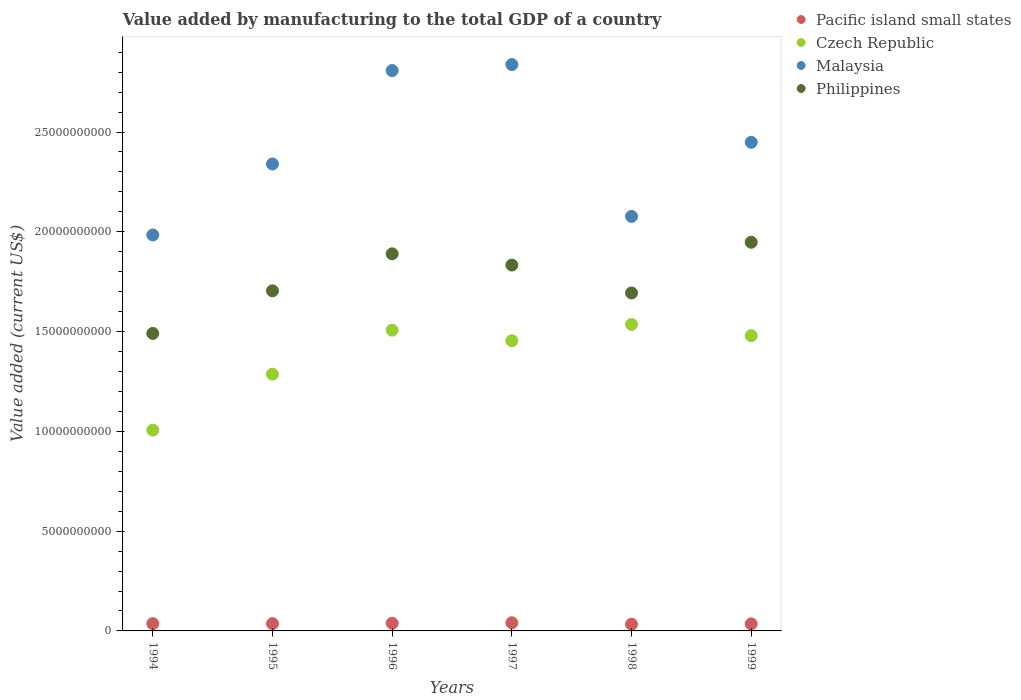How many different coloured dotlines are there?
Your response must be concise. 4. What is the value added by manufacturing to the total GDP in Philippines in 1997?
Offer a terse response. 1.83e+1. Across all years, what is the maximum value added by manufacturing to the total GDP in Malaysia?
Offer a terse response. 2.84e+1. Across all years, what is the minimum value added by manufacturing to the total GDP in Malaysia?
Your response must be concise. 1.98e+1. In which year was the value added by manufacturing to the total GDP in Philippines maximum?
Your response must be concise. 1999. What is the total value added by manufacturing to the total GDP in Malaysia in the graph?
Ensure brevity in your answer.  1.45e+11. What is the difference between the value added by manufacturing to the total GDP in Philippines in 1994 and that in 1999?
Your answer should be compact. -4.57e+09. What is the difference between the value added by manufacturing to the total GDP in Pacific island small states in 1994 and the value added by manufacturing to the total GDP in Philippines in 1999?
Offer a very short reply. -1.91e+1. What is the average value added by manufacturing to the total GDP in Malaysia per year?
Offer a very short reply. 2.42e+1. In the year 1995, what is the difference between the value added by manufacturing to the total GDP in Czech Republic and value added by manufacturing to the total GDP in Philippines?
Keep it short and to the point. -4.18e+09. In how many years, is the value added by manufacturing to the total GDP in Malaysia greater than 11000000000 US$?
Your response must be concise. 6. What is the ratio of the value added by manufacturing to the total GDP in Czech Republic in 1994 to that in 1995?
Provide a short and direct response. 0.78. What is the difference between the highest and the second highest value added by manufacturing to the total GDP in Malaysia?
Provide a short and direct response. 3.01e+08. What is the difference between the highest and the lowest value added by manufacturing to the total GDP in Philippines?
Ensure brevity in your answer.  4.57e+09. Is the sum of the value added by manufacturing to the total GDP in Malaysia in 1995 and 1999 greater than the maximum value added by manufacturing to the total GDP in Czech Republic across all years?
Keep it short and to the point. Yes. Is the value added by manufacturing to the total GDP in Philippines strictly greater than the value added by manufacturing to the total GDP in Czech Republic over the years?
Provide a succinct answer. Yes. Is the value added by manufacturing to the total GDP in Philippines strictly less than the value added by manufacturing to the total GDP in Pacific island small states over the years?
Offer a terse response. No. How many years are there in the graph?
Provide a short and direct response. 6. What is the difference between two consecutive major ticks on the Y-axis?
Offer a very short reply. 5.00e+09. Are the values on the major ticks of Y-axis written in scientific E-notation?
Offer a terse response. No. How are the legend labels stacked?
Provide a succinct answer. Vertical. What is the title of the graph?
Provide a short and direct response. Value added by manufacturing to the total GDP of a country. Does "West Bank and Gaza" appear as one of the legend labels in the graph?
Provide a short and direct response. No. What is the label or title of the X-axis?
Your answer should be very brief. Years. What is the label or title of the Y-axis?
Offer a very short reply. Value added (current US$). What is the Value added (current US$) of Pacific island small states in 1994?
Provide a succinct answer. 3.66e+08. What is the Value added (current US$) of Czech Republic in 1994?
Your answer should be compact. 1.01e+1. What is the Value added (current US$) of Malaysia in 1994?
Your answer should be compact. 1.98e+1. What is the Value added (current US$) in Philippines in 1994?
Offer a very short reply. 1.49e+1. What is the Value added (current US$) in Pacific island small states in 1995?
Your answer should be very brief. 3.65e+08. What is the Value added (current US$) in Czech Republic in 1995?
Make the answer very short. 1.29e+1. What is the Value added (current US$) in Malaysia in 1995?
Your response must be concise. 2.34e+1. What is the Value added (current US$) in Philippines in 1995?
Offer a terse response. 1.70e+1. What is the Value added (current US$) in Pacific island small states in 1996?
Offer a terse response. 3.83e+08. What is the Value added (current US$) in Czech Republic in 1996?
Your answer should be compact. 1.51e+1. What is the Value added (current US$) of Malaysia in 1996?
Your answer should be very brief. 2.81e+1. What is the Value added (current US$) of Philippines in 1996?
Ensure brevity in your answer.  1.89e+1. What is the Value added (current US$) in Pacific island small states in 1997?
Offer a terse response. 4.08e+08. What is the Value added (current US$) of Czech Republic in 1997?
Offer a terse response. 1.45e+1. What is the Value added (current US$) in Malaysia in 1997?
Ensure brevity in your answer.  2.84e+1. What is the Value added (current US$) of Philippines in 1997?
Your answer should be very brief. 1.83e+1. What is the Value added (current US$) in Pacific island small states in 1998?
Ensure brevity in your answer.  3.37e+08. What is the Value added (current US$) of Czech Republic in 1998?
Your answer should be compact. 1.54e+1. What is the Value added (current US$) of Malaysia in 1998?
Your response must be concise. 2.08e+1. What is the Value added (current US$) of Philippines in 1998?
Offer a very short reply. 1.69e+1. What is the Value added (current US$) of Pacific island small states in 1999?
Your answer should be very brief. 3.54e+08. What is the Value added (current US$) of Czech Republic in 1999?
Make the answer very short. 1.48e+1. What is the Value added (current US$) in Malaysia in 1999?
Offer a very short reply. 2.45e+1. What is the Value added (current US$) of Philippines in 1999?
Give a very brief answer. 1.95e+1. Across all years, what is the maximum Value added (current US$) in Pacific island small states?
Your answer should be compact. 4.08e+08. Across all years, what is the maximum Value added (current US$) in Czech Republic?
Provide a succinct answer. 1.54e+1. Across all years, what is the maximum Value added (current US$) in Malaysia?
Provide a succinct answer. 2.84e+1. Across all years, what is the maximum Value added (current US$) of Philippines?
Keep it short and to the point. 1.95e+1. Across all years, what is the minimum Value added (current US$) in Pacific island small states?
Your answer should be very brief. 3.37e+08. Across all years, what is the minimum Value added (current US$) of Czech Republic?
Your answer should be very brief. 1.01e+1. Across all years, what is the minimum Value added (current US$) in Malaysia?
Ensure brevity in your answer.  1.98e+1. Across all years, what is the minimum Value added (current US$) of Philippines?
Provide a succinct answer. 1.49e+1. What is the total Value added (current US$) of Pacific island small states in the graph?
Offer a terse response. 2.21e+09. What is the total Value added (current US$) of Czech Republic in the graph?
Keep it short and to the point. 8.27e+1. What is the total Value added (current US$) of Malaysia in the graph?
Give a very brief answer. 1.45e+11. What is the total Value added (current US$) of Philippines in the graph?
Your response must be concise. 1.06e+11. What is the difference between the Value added (current US$) in Pacific island small states in 1994 and that in 1995?
Make the answer very short. 1.14e+06. What is the difference between the Value added (current US$) in Czech Republic in 1994 and that in 1995?
Offer a terse response. -2.81e+09. What is the difference between the Value added (current US$) in Malaysia in 1994 and that in 1995?
Make the answer very short. -3.56e+09. What is the difference between the Value added (current US$) of Philippines in 1994 and that in 1995?
Make the answer very short. -2.14e+09. What is the difference between the Value added (current US$) of Pacific island small states in 1994 and that in 1996?
Your answer should be compact. -1.69e+07. What is the difference between the Value added (current US$) of Czech Republic in 1994 and that in 1996?
Offer a terse response. -5.01e+09. What is the difference between the Value added (current US$) in Malaysia in 1994 and that in 1996?
Your answer should be very brief. -8.24e+09. What is the difference between the Value added (current US$) in Philippines in 1994 and that in 1996?
Your response must be concise. -3.99e+09. What is the difference between the Value added (current US$) of Pacific island small states in 1994 and that in 1997?
Make the answer very short. -4.11e+07. What is the difference between the Value added (current US$) of Czech Republic in 1994 and that in 1997?
Provide a short and direct response. -4.48e+09. What is the difference between the Value added (current US$) of Malaysia in 1994 and that in 1997?
Keep it short and to the point. -8.54e+09. What is the difference between the Value added (current US$) in Philippines in 1994 and that in 1997?
Keep it short and to the point. -3.43e+09. What is the difference between the Value added (current US$) of Pacific island small states in 1994 and that in 1998?
Offer a very short reply. 2.93e+07. What is the difference between the Value added (current US$) in Czech Republic in 1994 and that in 1998?
Your response must be concise. -5.30e+09. What is the difference between the Value added (current US$) of Malaysia in 1994 and that in 1998?
Offer a very short reply. -9.30e+08. What is the difference between the Value added (current US$) in Philippines in 1994 and that in 1998?
Make the answer very short. -2.03e+09. What is the difference between the Value added (current US$) of Pacific island small states in 1994 and that in 1999?
Keep it short and to the point. 1.28e+07. What is the difference between the Value added (current US$) of Czech Republic in 1994 and that in 1999?
Ensure brevity in your answer.  -4.74e+09. What is the difference between the Value added (current US$) of Malaysia in 1994 and that in 1999?
Give a very brief answer. -4.64e+09. What is the difference between the Value added (current US$) in Philippines in 1994 and that in 1999?
Keep it short and to the point. -4.57e+09. What is the difference between the Value added (current US$) of Pacific island small states in 1995 and that in 1996?
Offer a very short reply. -1.80e+07. What is the difference between the Value added (current US$) in Czech Republic in 1995 and that in 1996?
Give a very brief answer. -2.21e+09. What is the difference between the Value added (current US$) of Malaysia in 1995 and that in 1996?
Provide a short and direct response. -4.68e+09. What is the difference between the Value added (current US$) in Philippines in 1995 and that in 1996?
Your response must be concise. -1.85e+09. What is the difference between the Value added (current US$) in Pacific island small states in 1995 and that in 1997?
Your answer should be very brief. -4.23e+07. What is the difference between the Value added (current US$) in Czech Republic in 1995 and that in 1997?
Your answer should be very brief. -1.68e+09. What is the difference between the Value added (current US$) in Malaysia in 1995 and that in 1997?
Your answer should be compact. -4.98e+09. What is the difference between the Value added (current US$) of Philippines in 1995 and that in 1997?
Your answer should be compact. -1.29e+09. What is the difference between the Value added (current US$) in Pacific island small states in 1995 and that in 1998?
Your response must be concise. 2.82e+07. What is the difference between the Value added (current US$) of Czech Republic in 1995 and that in 1998?
Give a very brief answer. -2.49e+09. What is the difference between the Value added (current US$) in Malaysia in 1995 and that in 1998?
Offer a terse response. 2.63e+09. What is the difference between the Value added (current US$) in Philippines in 1995 and that in 1998?
Provide a short and direct response. 1.06e+08. What is the difference between the Value added (current US$) of Pacific island small states in 1995 and that in 1999?
Your response must be concise. 1.17e+07. What is the difference between the Value added (current US$) of Czech Republic in 1995 and that in 1999?
Offer a very short reply. -1.93e+09. What is the difference between the Value added (current US$) of Malaysia in 1995 and that in 1999?
Provide a succinct answer. -1.09e+09. What is the difference between the Value added (current US$) in Philippines in 1995 and that in 1999?
Keep it short and to the point. -2.43e+09. What is the difference between the Value added (current US$) in Pacific island small states in 1996 and that in 1997?
Your answer should be compact. -2.43e+07. What is the difference between the Value added (current US$) in Czech Republic in 1996 and that in 1997?
Your response must be concise. 5.29e+08. What is the difference between the Value added (current US$) of Malaysia in 1996 and that in 1997?
Keep it short and to the point. -3.01e+08. What is the difference between the Value added (current US$) of Philippines in 1996 and that in 1997?
Your answer should be compact. 5.63e+08. What is the difference between the Value added (current US$) in Pacific island small states in 1996 and that in 1998?
Ensure brevity in your answer.  4.62e+07. What is the difference between the Value added (current US$) of Czech Republic in 1996 and that in 1998?
Ensure brevity in your answer.  -2.86e+08. What is the difference between the Value added (current US$) of Malaysia in 1996 and that in 1998?
Offer a terse response. 7.31e+09. What is the difference between the Value added (current US$) of Philippines in 1996 and that in 1998?
Keep it short and to the point. 1.96e+09. What is the difference between the Value added (current US$) of Pacific island small states in 1996 and that in 1999?
Offer a terse response. 2.97e+07. What is the difference between the Value added (current US$) of Czech Republic in 1996 and that in 1999?
Your response must be concise. 2.75e+08. What is the difference between the Value added (current US$) in Malaysia in 1996 and that in 1999?
Your answer should be compact. 3.60e+09. What is the difference between the Value added (current US$) of Philippines in 1996 and that in 1999?
Provide a short and direct response. -5.80e+08. What is the difference between the Value added (current US$) in Pacific island small states in 1997 and that in 1998?
Your answer should be compact. 7.04e+07. What is the difference between the Value added (current US$) of Czech Republic in 1997 and that in 1998?
Provide a short and direct response. -8.15e+08. What is the difference between the Value added (current US$) of Malaysia in 1997 and that in 1998?
Give a very brief answer. 7.61e+09. What is the difference between the Value added (current US$) of Philippines in 1997 and that in 1998?
Offer a very short reply. 1.40e+09. What is the difference between the Value added (current US$) in Pacific island small states in 1997 and that in 1999?
Your response must be concise. 5.40e+07. What is the difference between the Value added (current US$) in Czech Republic in 1997 and that in 1999?
Ensure brevity in your answer.  -2.54e+08. What is the difference between the Value added (current US$) in Malaysia in 1997 and that in 1999?
Your answer should be very brief. 3.90e+09. What is the difference between the Value added (current US$) in Philippines in 1997 and that in 1999?
Provide a succinct answer. -1.14e+09. What is the difference between the Value added (current US$) in Pacific island small states in 1998 and that in 1999?
Your response must be concise. -1.65e+07. What is the difference between the Value added (current US$) of Czech Republic in 1998 and that in 1999?
Offer a terse response. 5.62e+08. What is the difference between the Value added (current US$) in Malaysia in 1998 and that in 1999?
Provide a short and direct response. -3.71e+09. What is the difference between the Value added (current US$) of Philippines in 1998 and that in 1999?
Your response must be concise. -2.54e+09. What is the difference between the Value added (current US$) in Pacific island small states in 1994 and the Value added (current US$) in Czech Republic in 1995?
Keep it short and to the point. -1.25e+1. What is the difference between the Value added (current US$) in Pacific island small states in 1994 and the Value added (current US$) in Malaysia in 1995?
Give a very brief answer. -2.30e+1. What is the difference between the Value added (current US$) of Pacific island small states in 1994 and the Value added (current US$) of Philippines in 1995?
Your answer should be compact. -1.67e+1. What is the difference between the Value added (current US$) of Czech Republic in 1994 and the Value added (current US$) of Malaysia in 1995?
Your answer should be very brief. -1.33e+1. What is the difference between the Value added (current US$) of Czech Republic in 1994 and the Value added (current US$) of Philippines in 1995?
Provide a succinct answer. -6.98e+09. What is the difference between the Value added (current US$) of Malaysia in 1994 and the Value added (current US$) of Philippines in 1995?
Provide a succinct answer. 2.80e+09. What is the difference between the Value added (current US$) of Pacific island small states in 1994 and the Value added (current US$) of Czech Republic in 1996?
Provide a succinct answer. -1.47e+1. What is the difference between the Value added (current US$) of Pacific island small states in 1994 and the Value added (current US$) of Malaysia in 1996?
Your response must be concise. -2.77e+1. What is the difference between the Value added (current US$) of Pacific island small states in 1994 and the Value added (current US$) of Philippines in 1996?
Make the answer very short. -1.85e+1. What is the difference between the Value added (current US$) in Czech Republic in 1994 and the Value added (current US$) in Malaysia in 1996?
Your answer should be compact. -1.80e+1. What is the difference between the Value added (current US$) of Czech Republic in 1994 and the Value added (current US$) of Philippines in 1996?
Ensure brevity in your answer.  -8.84e+09. What is the difference between the Value added (current US$) in Malaysia in 1994 and the Value added (current US$) in Philippines in 1996?
Your answer should be compact. 9.45e+08. What is the difference between the Value added (current US$) in Pacific island small states in 1994 and the Value added (current US$) in Czech Republic in 1997?
Provide a short and direct response. -1.42e+1. What is the difference between the Value added (current US$) of Pacific island small states in 1994 and the Value added (current US$) of Malaysia in 1997?
Provide a succinct answer. -2.80e+1. What is the difference between the Value added (current US$) of Pacific island small states in 1994 and the Value added (current US$) of Philippines in 1997?
Offer a terse response. -1.80e+1. What is the difference between the Value added (current US$) in Czech Republic in 1994 and the Value added (current US$) in Malaysia in 1997?
Keep it short and to the point. -1.83e+1. What is the difference between the Value added (current US$) of Czech Republic in 1994 and the Value added (current US$) of Philippines in 1997?
Your response must be concise. -8.27e+09. What is the difference between the Value added (current US$) in Malaysia in 1994 and the Value added (current US$) in Philippines in 1997?
Give a very brief answer. 1.51e+09. What is the difference between the Value added (current US$) in Pacific island small states in 1994 and the Value added (current US$) in Czech Republic in 1998?
Make the answer very short. -1.50e+1. What is the difference between the Value added (current US$) in Pacific island small states in 1994 and the Value added (current US$) in Malaysia in 1998?
Offer a very short reply. -2.04e+1. What is the difference between the Value added (current US$) of Pacific island small states in 1994 and the Value added (current US$) of Philippines in 1998?
Offer a very short reply. -1.66e+1. What is the difference between the Value added (current US$) of Czech Republic in 1994 and the Value added (current US$) of Malaysia in 1998?
Offer a terse response. -1.07e+1. What is the difference between the Value added (current US$) of Czech Republic in 1994 and the Value added (current US$) of Philippines in 1998?
Keep it short and to the point. -6.88e+09. What is the difference between the Value added (current US$) in Malaysia in 1994 and the Value added (current US$) in Philippines in 1998?
Offer a very short reply. 2.90e+09. What is the difference between the Value added (current US$) in Pacific island small states in 1994 and the Value added (current US$) in Czech Republic in 1999?
Offer a very short reply. -1.44e+1. What is the difference between the Value added (current US$) in Pacific island small states in 1994 and the Value added (current US$) in Malaysia in 1999?
Offer a very short reply. -2.41e+1. What is the difference between the Value added (current US$) in Pacific island small states in 1994 and the Value added (current US$) in Philippines in 1999?
Your response must be concise. -1.91e+1. What is the difference between the Value added (current US$) of Czech Republic in 1994 and the Value added (current US$) of Malaysia in 1999?
Ensure brevity in your answer.  -1.44e+1. What is the difference between the Value added (current US$) in Czech Republic in 1994 and the Value added (current US$) in Philippines in 1999?
Provide a succinct answer. -9.42e+09. What is the difference between the Value added (current US$) in Malaysia in 1994 and the Value added (current US$) in Philippines in 1999?
Offer a terse response. 3.65e+08. What is the difference between the Value added (current US$) of Pacific island small states in 1995 and the Value added (current US$) of Czech Republic in 1996?
Ensure brevity in your answer.  -1.47e+1. What is the difference between the Value added (current US$) in Pacific island small states in 1995 and the Value added (current US$) in Malaysia in 1996?
Provide a short and direct response. -2.77e+1. What is the difference between the Value added (current US$) of Pacific island small states in 1995 and the Value added (current US$) of Philippines in 1996?
Keep it short and to the point. -1.85e+1. What is the difference between the Value added (current US$) in Czech Republic in 1995 and the Value added (current US$) in Malaysia in 1996?
Offer a very short reply. -1.52e+1. What is the difference between the Value added (current US$) of Czech Republic in 1995 and the Value added (current US$) of Philippines in 1996?
Your answer should be very brief. -6.03e+09. What is the difference between the Value added (current US$) of Malaysia in 1995 and the Value added (current US$) of Philippines in 1996?
Keep it short and to the point. 4.50e+09. What is the difference between the Value added (current US$) of Pacific island small states in 1995 and the Value added (current US$) of Czech Republic in 1997?
Your answer should be compact. -1.42e+1. What is the difference between the Value added (current US$) of Pacific island small states in 1995 and the Value added (current US$) of Malaysia in 1997?
Your answer should be compact. -2.80e+1. What is the difference between the Value added (current US$) of Pacific island small states in 1995 and the Value added (current US$) of Philippines in 1997?
Make the answer very short. -1.80e+1. What is the difference between the Value added (current US$) in Czech Republic in 1995 and the Value added (current US$) in Malaysia in 1997?
Your answer should be compact. -1.55e+1. What is the difference between the Value added (current US$) in Czech Republic in 1995 and the Value added (current US$) in Philippines in 1997?
Give a very brief answer. -5.47e+09. What is the difference between the Value added (current US$) in Malaysia in 1995 and the Value added (current US$) in Philippines in 1997?
Your answer should be very brief. 5.07e+09. What is the difference between the Value added (current US$) of Pacific island small states in 1995 and the Value added (current US$) of Czech Republic in 1998?
Offer a terse response. -1.50e+1. What is the difference between the Value added (current US$) of Pacific island small states in 1995 and the Value added (current US$) of Malaysia in 1998?
Make the answer very short. -2.04e+1. What is the difference between the Value added (current US$) of Pacific island small states in 1995 and the Value added (current US$) of Philippines in 1998?
Ensure brevity in your answer.  -1.66e+1. What is the difference between the Value added (current US$) of Czech Republic in 1995 and the Value added (current US$) of Malaysia in 1998?
Ensure brevity in your answer.  -7.90e+09. What is the difference between the Value added (current US$) in Czech Republic in 1995 and the Value added (current US$) in Philippines in 1998?
Your answer should be compact. -4.07e+09. What is the difference between the Value added (current US$) of Malaysia in 1995 and the Value added (current US$) of Philippines in 1998?
Keep it short and to the point. 6.46e+09. What is the difference between the Value added (current US$) of Pacific island small states in 1995 and the Value added (current US$) of Czech Republic in 1999?
Your answer should be very brief. -1.44e+1. What is the difference between the Value added (current US$) of Pacific island small states in 1995 and the Value added (current US$) of Malaysia in 1999?
Your answer should be compact. -2.41e+1. What is the difference between the Value added (current US$) of Pacific island small states in 1995 and the Value added (current US$) of Philippines in 1999?
Provide a short and direct response. -1.91e+1. What is the difference between the Value added (current US$) of Czech Republic in 1995 and the Value added (current US$) of Malaysia in 1999?
Provide a succinct answer. -1.16e+1. What is the difference between the Value added (current US$) in Czech Republic in 1995 and the Value added (current US$) in Philippines in 1999?
Keep it short and to the point. -6.61e+09. What is the difference between the Value added (current US$) in Malaysia in 1995 and the Value added (current US$) in Philippines in 1999?
Provide a succinct answer. 3.92e+09. What is the difference between the Value added (current US$) of Pacific island small states in 1996 and the Value added (current US$) of Czech Republic in 1997?
Provide a short and direct response. -1.42e+1. What is the difference between the Value added (current US$) of Pacific island small states in 1996 and the Value added (current US$) of Malaysia in 1997?
Make the answer very short. -2.80e+1. What is the difference between the Value added (current US$) in Pacific island small states in 1996 and the Value added (current US$) in Philippines in 1997?
Keep it short and to the point. -1.80e+1. What is the difference between the Value added (current US$) in Czech Republic in 1996 and the Value added (current US$) in Malaysia in 1997?
Make the answer very short. -1.33e+1. What is the difference between the Value added (current US$) of Czech Republic in 1996 and the Value added (current US$) of Philippines in 1997?
Make the answer very short. -3.26e+09. What is the difference between the Value added (current US$) in Malaysia in 1996 and the Value added (current US$) in Philippines in 1997?
Offer a terse response. 9.75e+09. What is the difference between the Value added (current US$) of Pacific island small states in 1996 and the Value added (current US$) of Czech Republic in 1998?
Provide a short and direct response. -1.50e+1. What is the difference between the Value added (current US$) of Pacific island small states in 1996 and the Value added (current US$) of Malaysia in 1998?
Your response must be concise. -2.04e+1. What is the difference between the Value added (current US$) of Pacific island small states in 1996 and the Value added (current US$) of Philippines in 1998?
Keep it short and to the point. -1.66e+1. What is the difference between the Value added (current US$) of Czech Republic in 1996 and the Value added (current US$) of Malaysia in 1998?
Your response must be concise. -5.70e+09. What is the difference between the Value added (current US$) in Czech Republic in 1996 and the Value added (current US$) in Philippines in 1998?
Offer a very short reply. -1.86e+09. What is the difference between the Value added (current US$) of Malaysia in 1996 and the Value added (current US$) of Philippines in 1998?
Your response must be concise. 1.11e+1. What is the difference between the Value added (current US$) in Pacific island small states in 1996 and the Value added (current US$) in Czech Republic in 1999?
Offer a very short reply. -1.44e+1. What is the difference between the Value added (current US$) of Pacific island small states in 1996 and the Value added (current US$) of Malaysia in 1999?
Provide a short and direct response. -2.41e+1. What is the difference between the Value added (current US$) in Pacific island small states in 1996 and the Value added (current US$) in Philippines in 1999?
Provide a succinct answer. -1.91e+1. What is the difference between the Value added (current US$) of Czech Republic in 1996 and the Value added (current US$) of Malaysia in 1999?
Provide a succinct answer. -9.41e+09. What is the difference between the Value added (current US$) in Czech Republic in 1996 and the Value added (current US$) in Philippines in 1999?
Offer a very short reply. -4.40e+09. What is the difference between the Value added (current US$) in Malaysia in 1996 and the Value added (current US$) in Philippines in 1999?
Make the answer very short. 8.60e+09. What is the difference between the Value added (current US$) of Pacific island small states in 1997 and the Value added (current US$) of Czech Republic in 1998?
Ensure brevity in your answer.  -1.50e+1. What is the difference between the Value added (current US$) in Pacific island small states in 1997 and the Value added (current US$) in Malaysia in 1998?
Make the answer very short. -2.04e+1. What is the difference between the Value added (current US$) of Pacific island small states in 1997 and the Value added (current US$) of Philippines in 1998?
Your response must be concise. -1.65e+1. What is the difference between the Value added (current US$) in Czech Republic in 1997 and the Value added (current US$) in Malaysia in 1998?
Provide a succinct answer. -6.23e+09. What is the difference between the Value added (current US$) in Czech Republic in 1997 and the Value added (current US$) in Philippines in 1998?
Provide a short and direct response. -2.39e+09. What is the difference between the Value added (current US$) of Malaysia in 1997 and the Value added (current US$) of Philippines in 1998?
Keep it short and to the point. 1.14e+1. What is the difference between the Value added (current US$) of Pacific island small states in 1997 and the Value added (current US$) of Czech Republic in 1999?
Ensure brevity in your answer.  -1.44e+1. What is the difference between the Value added (current US$) in Pacific island small states in 1997 and the Value added (current US$) in Malaysia in 1999?
Offer a very short reply. -2.41e+1. What is the difference between the Value added (current US$) in Pacific island small states in 1997 and the Value added (current US$) in Philippines in 1999?
Provide a short and direct response. -1.91e+1. What is the difference between the Value added (current US$) of Czech Republic in 1997 and the Value added (current US$) of Malaysia in 1999?
Keep it short and to the point. -9.94e+09. What is the difference between the Value added (current US$) of Czech Republic in 1997 and the Value added (current US$) of Philippines in 1999?
Your answer should be very brief. -4.93e+09. What is the difference between the Value added (current US$) of Malaysia in 1997 and the Value added (current US$) of Philippines in 1999?
Offer a terse response. 8.90e+09. What is the difference between the Value added (current US$) in Pacific island small states in 1998 and the Value added (current US$) in Czech Republic in 1999?
Offer a terse response. -1.45e+1. What is the difference between the Value added (current US$) in Pacific island small states in 1998 and the Value added (current US$) in Malaysia in 1999?
Provide a short and direct response. -2.41e+1. What is the difference between the Value added (current US$) of Pacific island small states in 1998 and the Value added (current US$) of Philippines in 1999?
Keep it short and to the point. -1.91e+1. What is the difference between the Value added (current US$) in Czech Republic in 1998 and the Value added (current US$) in Malaysia in 1999?
Ensure brevity in your answer.  -9.13e+09. What is the difference between the Value added (current US$) of Czech Republic in 1998 and the Value added (current US$) of Philippines in 1999?
Make the answer very short. -4.12e+09. What is the difference between the Value added (current US$) of Malaysia in 1998 and the Value added (current US$) of Philippines in 1999?
Offer a terse response. 1.30e+09. What is the average Value added (current US$) of Pacific island small states per year?
Give a very brief answer. 3.69e+08. What is the average Value added (current US$) of Czech Republic per year?
Offer a very short reply. 1.38e+1. What is the average Value added (current US$) of Malaysia per year?
Keep it short and to the point. 2.42e+1. What is the average Value added (current US$) in Philippines per year?
Your answer should be very brief. 1.76e+1. In the year 1994, what is the difference between the Value added (current US$) in Pacific island small states and Value added (current US$) in Czech Republic?
Give a very brief answer. -9.69e+09. In the year 1994, what is the difference between the Value added (current US$) of Pacific island small states and Value added (current US$) of Malaysia?
Your response must be concise. -1.95e+1. In the year 1994, what is the difference between the Value added (current US$) in Pacific island small states and Value added (current US$) in Philippines?
Provide a succinct answer. -1.45e+1. In the year 1994, what is the difference between the Value added (current US$) of Czech Republic and Value added (current US$) of Malaysia?
Your answer should be very brief. -9.78e+09. In the year 1994, what is the difference between the Value added (current US$) of Czech Republic and Value added (current US$) of Philippines?
Make the answer very short. -4.85e+09. In the year 1994, what is the difference between the Value added (current US$) of Malaysia and Value added (current US$) of Philippines?
Provide a short and direct response. 4.93e+09. In the year 1995, what is the difference between the Value added (current US$) in Pacific island small states and Value added (current US$) in Czech Republic?
Ensure brevity in your answer.  -1.25e+1. In the year 1995, what is the difference between the Value added (current US$) of Pacific island small states and Value added (current US$) of Malaysia?
Keep it short and to the point. -2.30e+1. In the year 1995, what is the difference between the Value added (current US$) of Pacific island small states and Value added (current US$) of Philippines?
Your answer should be very brief. -1.67e+1. In the year 1995, what is the difference between the Value added (current US$) in Czech Republic and Value added (current US$) in Malaysia?
Provide a succinct answer. -1.05e+1. In the year 1995, what is the difference between the Value added (current US$) of Czech Republic and Value added (current US$) of Philippines?
Give a very brief answer. -4.18e+09. In the year 1995, what is the difference between the Value added (current US$) in Malaysia and Value added (current US$) in Philippines?
Keep it short and to the point. 6.36e+09. In the year 1996, what is the difference between the Value added (current US$) in Pacific island small states and Value added (current US$) in Czech Republic?
Ensure brevity in your answer.  -1.47e+1. In the year 1996, what is the difference between the Value added (current US$) of Pacific island small states and Value added (current US$) of Malaysia?
Provide a short and direct response. -2.77e+1. In the year 1996, what is the difference between the Value added (current US$) in Pacific island small states and Value added (current US$) in Philippines?
Provide a succinct answer. -1.85e+1. In the year 1996, what is the difference between the Value added (current US$) in Czech Republic and Value added (current US$) in Malaysia?
Give a very brief answer. -1.30e+1. In the year 1996, what is the difference between the Value added (current US$) in Czech Republic and Value added (current US$) in Philippines?
Provide a succinct answer. -3.82e+09. In the year 1996, what is the difference between the Value added (current US$) in Malaysia and Value added (current US$) in Philippines?
Give a very brief answer. 9.18e+09. In the year 1997, what is the difference between the Value added (current US$) of Pacific island small states and Value added (current US$) of Czech Republic?
Give a very brief answer. -1.41e+1. In the year 1997, what is the difference between the Value added (current US$) of Pacific island small states and Value added (current US$) of Malaysia?
Keep it short and to the point. -2.80e+1. In the year 1997, what is the difference between the Value added (current US$) of Pacific island small states and Value added (current US$) of Philippines?
Give a very brief answer. -1.79e+1. In the year 1997, what is the difference between the Value added (current US$) in Czech Republic and Value added (current US$) in Malaysia?
Offer a very short reply. -1.38e+1. In the year 1997, what is the difference between the Value added (current US$) in Czech Republic and Value added (current US$) in Philippines?
Ensure brevity in your answer.  -3.79e+09. In the year 1997, what is the difference between the Value added (current US$) in Malaysia and Value added (current US$) in Philippines?
Offer a terse response. 1.00e+1. In the year 1998, what is the difference between the Value added (current US$) in Pacific island small states and Value added (current US$) in Czech Republic?
Give a very brief answer. -1.50e+1. In the year 1998, what is the difference between the Value added (current US$) of Pacific island small states and Value added (current US$) of Malaysia?
Provide a succinct answer. -2.04e+1. In the year 1998, what is the difference between the Value added (current US$) of Pacific island small states and Value added (current US$) of Philippines?
Make the answer very short. -1.66e+1. In the year 1998, what is the difference between the Value added (current US$) in Czech Republic and Value added (current US$) in Malaysia?
Ensure brevity in your answer.  -5.41e+09. In the year 1998, what is the difference between the Value added (current US$) in Czech Republic and Value added (current US$) in Philippines?
Give a very brief answer. -1.58e+09. In the year 1998, what is the difference between the Value added (current US$) of Malaysia and Value added (current US$) of Philippines?
Provide a short and direct response. 3.83e+09. In the year 1999, what is the difference between the Value added (current US$) of Pacific island small states and Value added (current US$) of Czech Republic?
Offer a terse response. -1.44e+1. In the year 1999, what is the difference between the Value added (current US$) in Pacific island small states and Value added (current US$) in Malaysia?
Your response must be concise. -2.41e+1. In the year 1999, what is the difference between the Value added (current US$) in Pacific island small states and Value added (current US$) in Philippines?
Give a very brief answer. -1.91e+1. In the year 1999, what is the difference between the Value added (current US$) in Czech Republic and Value added (current US$) in Malaysia?
Your answer should be very brief. -9.69e+09. In the year 1999, what is the difference between the Value added (current US$) in Czech Republic and Value added (current US$) in Philippines?
Provide a succinct answer. -4.68e+09. In the year 1999, what is the difference between the Value added (current US$) in Malaysia and Value added (current US$) in Philippines?
Your answer should be compact. 5.01e+09. What is the ratio of the Value added (current US$) in Pacific island small states in 1994 to that in 1995?
Your answer should be very brief. 1. What is the ratio of the Value added (current US$) in Czech Republic in 1994 to that in 1995?
Give a very brief answer. 0.78. What is the ratio of the Value added (current US$) in Malaysia in 1994 to that in 1995?
Provide a succinct answer. 0.85. What is the ratio of the Value added (current US$) of Philippines in 1994 to that in 1995?
Ensure brevity in your answer.  0.87. What is the ratio of the Value added (current US$) of Pacific island small states in 1994 to that in 1996?
Provide a short and direct response. 0.96. What is the ratio of the Value added (current US$) in Czech Republic in 1994 to that in 1996?
Provide a short and direct response. 0.67. What is the ratio of the Value added (current US$) of Malaysia in 1994 to that in 1996?
Provide a succinct answer. 0.71. What is the ratio of the Value added (current US$) in Philippines in 1994 to that in 1996?
Keep it short and to the point. 0.79. What is the ratio of the Value added (current US$) in Pacific island small states in 1994 to that in 1997?
Offer a very short reply. 0.9. What is the ratio of the Value added (current US$) in Czech Republic in 1994 to that in 1997?
Offer a terse response. 0.69. What is the ratio of the Value added (current US$) in Malaysia in 1994 to that in 1997?
Your response must be concise. 0.7. What is the ratio of the Value added (current US$) of Philippines in 1994 to that in 1997?
Make the answer very short. 0.81. What is the ratio of the Value added (current US$) in Pacific island small states in 1994 to that in 1998?
Make the answer very short. 1.09. What is the ratio of the Value added (current US$) in Czech Republic in 1994 to that in 1998?
Your answer should be very brief. 0.66. What is the ratio of the Value added (current US$) in Malaysia in 1994 to that in 1998?
Your answer should be compact. 0.96. What is the ratio of the Value added (current US$) in Philippines in 1994 to that in 1998?
Keep it short and to the point. 0.88. What is the ratio of the Value added (current US$) in Pacific island small states in 1994 to that in 1999?
Make the answer very short. 1.04. What is the ratio of the Value added (current US$) in Czech Republic in 1994 to that in 1999?
Provide a succinct answer. 0.68. What is the ratio of the Value added (current US$) of Malaysia in 1994 to that in 1999?
Give a very brief answer. 0.81. What is the ratio of the Value added (current US$) in Philippines in 1994 to that in 1999?
Provide a short and direct response. 0.77. What is the ratio of the Value added (current US$) in Pacific island small states in 1995 to that in 1996?
Offer a terse response. 0.95. What is the ratio of the Value added (current US$) in Czech Republic in 1995 to that in 1996?
Make the answer very short. 0.85. What is the ratio of the Value added (current US$) in Philippines in 1995 to that in 1996?
Make the answer very short. 0.9. What is the ratio of the Value added (current US$) of Pacific island small states in 1995 to that in 1997?
Ensure brevity in your answer.  0.9. What is the ratio of the Value added (current US$) in Czech Republic in 1995 to that in 1997?
Make the answer very short. 0.88. What is the ratio of the Value added (current US$) in Malaysia in 1995 to that in 1997?
Keep it short and to the point. 0.82. What is the ratio of the Value added (current US$) of Philippines in 1995 to that in 1997?
Your answer should be very brief. 0.93. What is the ratio of the Value added (current US$) in Pacific island small states in 1995 to that in 1998?
Provide a short and direct response. 1.08. What is the ratio of the Value added (current US$) in Czech Republic in 1995 to that in 1998?
Your answer should be very brief. 0.84. What is the ratio of the Value added (current US$) in Malaysia in 1995 to that in 1998?
Offer a terse response. 1.13. What is the ratio of the Value added (current US$) in Philippines in 1995 to that in 1998?
Provide a short and direct response. 1.01. What is the ratio of the Value added (current US$) of Pacific island small states in 1995 to that in 1999?
Your answer should be compact. 1.03. What is the ratio of the Value added (current US$) in Czech Republic in 1995 to that in 1999?
Your answer should be very brief. 0.87. What is the ratio of the Value added (current US$) of Malaysia in 1995 to that in 1999?
Keep it short and to the point. 0.96. What is the ratio of the Value added (current US$) in Pacific island small states in 1996 to that in 1997?
Offer a very short reply. 0.94. What is the ratio of the Value added (current US$) in Czech Republic in 1996 to that in 1997?
Offer a very short reply. 1.04. What is the ratio of the Value added (current US$) in Malaysia in 1996 to that in 1997?
Make the answer very short. 0.99. What is the ratio of the Value added (current US$) in Philippines in 1996 to that in 1997?
Offer a very short reply. 1.03. What is the ratio of the Value added (current US$) in Pacific island small states in 1996 to that in 1998?
Your answer should be very brief. 1.14. What is the ratio of the Value added (current US$) in Czech Republic in 1996 to that in 1998?
Your response must be concise. 0.98. What is the ratio of the Value added (current US$) of Malaysia in 1996 to that in 1998?
Provide a succinct answer. 1.35. What is the ratio of the Value added (current US$) in Philippines in 1996 to that in 1998?
Your answer should be compact. 1.12. What is the ratio of the Value added (current US$) in Pacific island small states in 1996 to that in 1999?
Your answer should be compact. 1.08. What is the ratio of the Value added (current US$) in Czech Republic in 1996 to that in 1999?
Your answer should be very brief. 1.02. What is the ratio of the Value added (current US$) in Malaysia in 1996 to that in 1999?
Offer a very short reply. 1.15. What is the ratio of the Value added (current US$) in Philippines in 1996 to that in 1999?
Make the answer very short. 0.97. What is the ratio of the Value added (current US$) of Pacific island small states in 1997 to that in 1998?
Provide a short and direct response. 1.21. What is the ratio of the Value added (current US$) in Czech Republic in 1997 to that in 1998?
Offer a very short reply. 0.95. What is the ratio of the Value added (current US$) of Malaysia in 1997 to that in 1998?
Offer a very short reply. 1.37. What is the ratio of the Value added (current US$) of Philippines in 1997 to that in 1998?
Give a very brief answer. 1.08. What is the ratio of the Value added (current US$) of Pacific island small states in 1997 to that in 1999?
Your answer should be compact. 1.15. What is the ratio of the Value added (current US$) in Czech Republic in 1997 to that in 1999?
Provide a succinct answer. 0.98. What is the ratio of the Value added (current US$) in Malaysia in 1997 to that in 1999?
Your response must be concise. 1.16. What is the ratio of the Value added (current US$) of Philippines in 1997 to that in 1999?
Give a very brief answer. 0.94. What is the ratio of the Value added (current US$) of Pacific island small states in 1998 to that in 1999?
Your answer should be compact. 0.95. What is the ratio of the Value added (current US$) of Czech Republic in 1998 to that in 1999?
Offer a very short reply. 1.04. What is the ratio of the Value added (current US$) in Malaysia in 1998 to that in 1999?
Your answer should be very brief. 0.85. What is the ratio of the Value added (current US$) in Philippines in 1998 to that in 1999?
Offer a terse response. 0.87. What is the difference between the highest and the second highest Value added (current US$) of Pacific island small states?
Offer a very short reply. 2.43e+07. What is the difference between the highest and the second highest Value added (current US$) in Czech Republic?
Provide a succinct answer. 2.86e+08. What is the difference between the highest and the second highest Value added (current US$) of Malaysia?
Give a very brief answer. 3.01e+08. What is the difference between the highest and the second highest Value added (current US$) of Philippines?
Keep it short and to the point. 5.80e+08. What is the difference between the highest and the lowest Value added (current US$) of Pacific island small states?
Make the answer very short. 7.04e+07. What is the difference between the highest and the lowest Value added (current US$) of Czech Republic?
Your response must be concise. 5.30e+09. What is the difference between the highest and the lowest Value added (current US$) in Malaysia?
Offer a terse response. 8.54e+09. What is the difference between the highest and the lowest Value added (current US$) of Philippines?
Make the answer very short. 4.57e+09. 